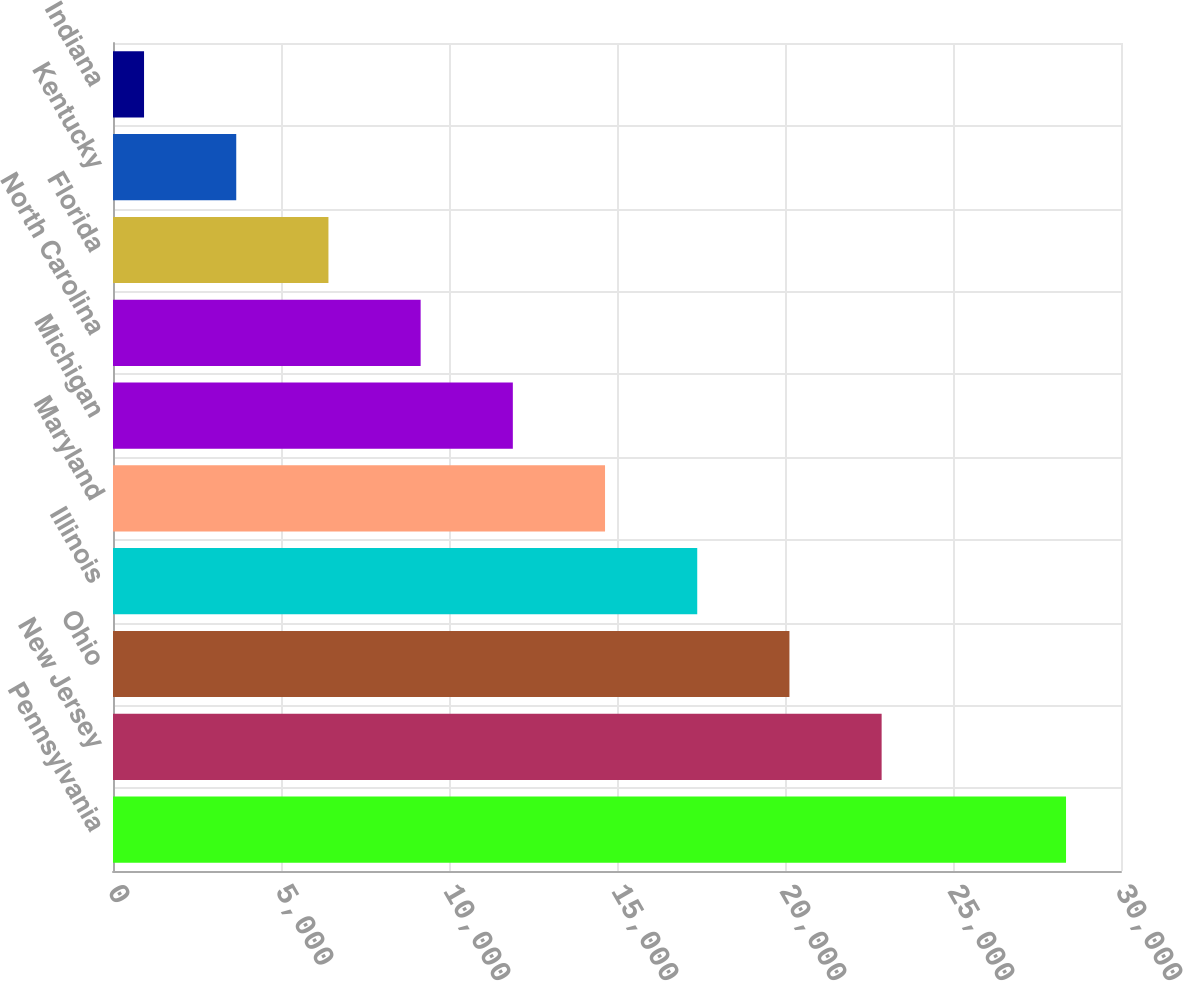Convert chart to OTSL. <chart><loc_0><loc_0><loc_500><loc_500><bar_chart><fcel>Pennsylvania<fcel>New Jersey<fcel>Ohio<fcel>Illinois<fcel>Maryland<fcel>Michigan<fcel>North Carolina<fcel>Florida<fcel>Kentucky<fcel>Indiana<nl><fcel>28364<fcel>22876<fcel>20132<fcel>17388<fcel>14644<fcel>11900<fcel>9156<fcel>6412<fcel>3668<fcel>924<nl></chart> 